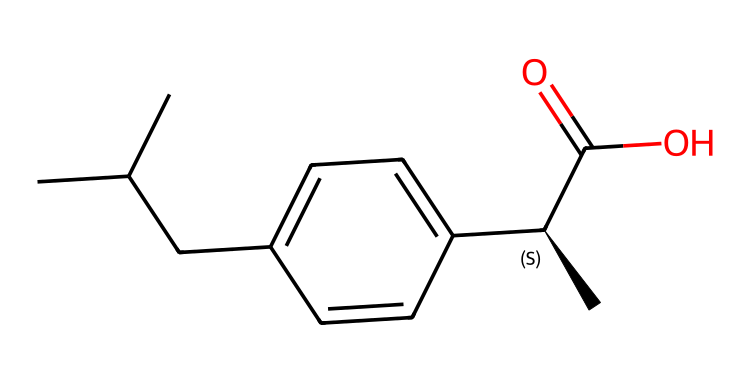What is the molecular formula of ibuprofen? The SMILES representation can be translated to find the number of each type of atom. Counting the carbons (C), hydrogens (H), and oxygens (O) gives the molecular formula. There are 13 carbons, 18 hydrogens, and 2 oxygens, leading to the formula C13H18O2.
Answer: C13H18O2 How many chiral centers are present in ibuprofen? By analyzing the structure, we look for carbon atoms connected to four unique groups, which indicates chirality. In the structure given, there is one carbon (the one denoted with [C@H]) that is attached to four different substituents, indicating one chiral center.
Answer: 1 What functional group is present in ibuprofen? The -C(=O)O part of the structure indicates a carboxylic acid functional group, which is characterized by a carbon atom double-bonded to an oxygen atom and single-bonded to a hydroxyl group (-OH). This is evident in the structure.
Answer: carboxylic acid How many double bonds are in ibuprofen? In the SMILES notation, the part "C(=O)" indicates a double bond between a carbon and an oxygen, while there are no other double bonds explicitly shown in other parts of the structure. Therefore, there is only one double bond.
Answer: 1 What is the common use of ibuprofen? Ibuprofen is widely recognized for its use as a nonsteroidal anti-inflammatory drug (NSAID), which is primarily used to relieve pain, reduce inflammation, and lower fever. This application is well-known in medicinal chemistry.
Answer: pain reliever What does the "C(C)C" portion signify in ibuprofen? The "C(C)C" portion indicates a branched alkyl group, specifically isobutyl. This branching contributes to the hydrophobic character of ibuprofen, impacting its pharmacokinetics and overall efficacy as a drug.
Answer: branched alkyl group What type of isomerism is exhibited by ibuprofen? The presence of a chiral center leads to the existence of enantiomers, which are stereoisomers that are mirror images of each other. In this case, ibuprofen exists as two enantiomers due to its single chiral carbon.
Answer: enantiomerism 